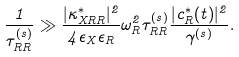<formula> <loc_0><loc_0><loc_500><loc_500>\frac { 1 } { \tau ^ { ( s ) } _ { R R } } \gg \frac { | \kappa ^ { * } _ { X R R } | ^ { 2 } } { 4 \epsilon _ { X } \epsilon _ { R } } \omega _ { R } ^ { 2 } \tau ^ { ( s ) } _ { R R } \frac { | c _ { R } ^ { * } ( t ) | ^ { 2 } } { { \gamma ^ { ( s ) } } } .</formula> 